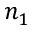<formula> <loc_0><loc_0><loc_500><loc_500>n _ { 1 }</formula> 